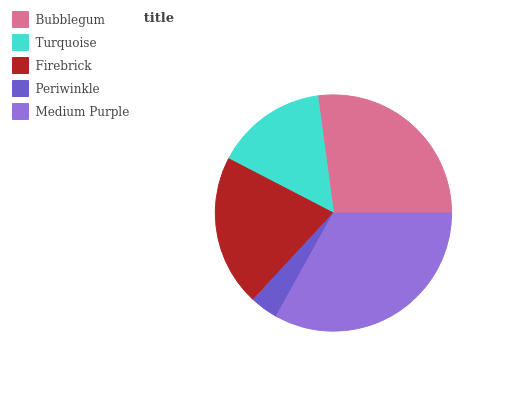Is Periwinkle the minimum?
Answer yes or no. Yes. Is Medium Purple the maximum?
Answer yes or no. Yes. Is Turquoise the minimum?
Answer yes or no. No. Is Turquoise the maximum?
Answer yes or no. No. Is Bubblegum greater than Turquoise?
Answer yes or no. Yes. Is Turquoise less than Bubblegum?
Answer yes or no. Yes. Is Turquoise greater than Bubblegum?
Answer yes or no. No. Is Bubblegum less than Turquoise?
Answer yes or no. No. Is Firebrick the high median?
Answer yes or no. Yes. Is Firebrick the low median?
Answer yes or no. Yes. Is Medium Purple the high median?
Answer yes or no. No. Is Periwinkle the low median?
Answer yes or no. No. 